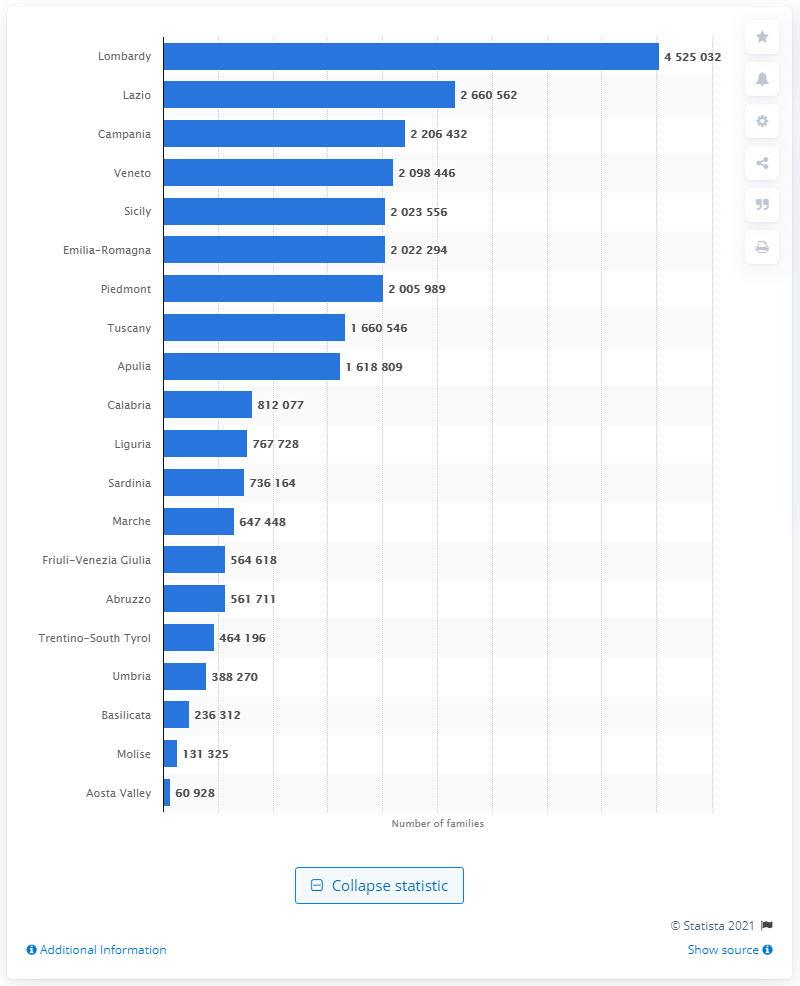List a handful of essential elements in this visual. In 2019, the population of Lazio and Campania was 2,206,432. In 2019, there were approximately 45,250,328 families living in the region of Lombardy. Lombardy has the highest population among all regions in Italy. 